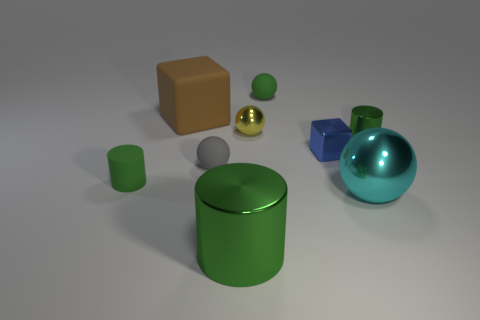There is a large green metallic cylinder; are there any shiny cylinders behind it?
Keep it short and to the point. Yes. The big metal ball is what color?
Your response must be concise. Cyan. There is a large shiny cylinder; is it the same color as the small cylinder right of the tiny matte cylinder?
Make the answer very short. Yes. Are there any cyan shiny spheres that have the same size as the brown cube?
Give a very brief answer. Yes. There is a metallic object that is the same color as the big cylinder; what size is it?
Keep it short and to the point. Small. What is the block in front of the large rubber block made of?
Keep it short and to the point. Metal. Are there an equal number of big green shiny objects that are to the right of the cyan metal ball and small green cylinders on the right side of the yellow shiny thing?
Provide a short and direct response. No. There is a rubber thing to the left of the big matte thing; is it the same size as the metal sphere that is behind the small metal cube?
Your response must be concise. Yes. What number of rubber things are the same color as the large shiny cylinder?
Offer a terse response. 2. There is another small cylinder that is the same color as the small rubber cylinder; what material is it?
Make the answer very short. Metal. 